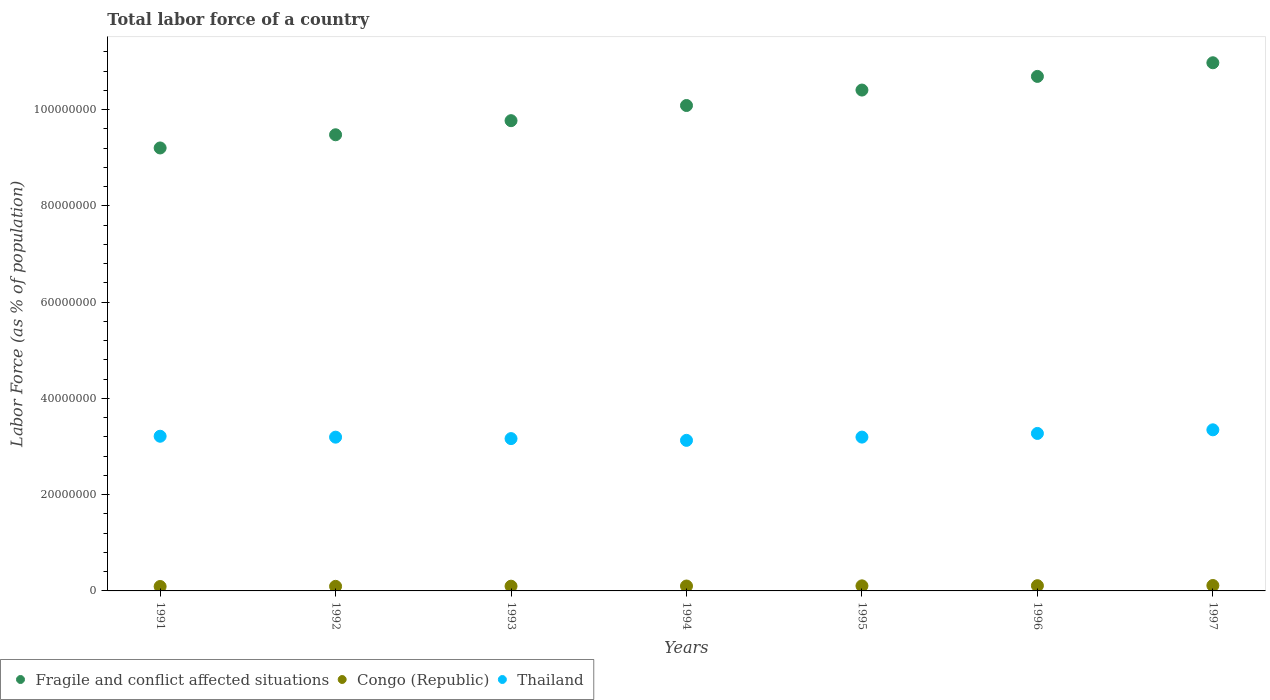How many different coloured dotlines are there?
Your answer should be very brief. 3. Is the number of dotlines equal to the number of legend labels?
Your answer should be compact. Yes. What is the percentage of labor force in Thailand in 1995?
Your answer should be compact. 3.20e+07. Across all years, what is the maximum percentage of labor force in Thailand?
Your answer should be very brief. 3.35e+07. Across all years, what is the minimum percentage of labor force in Thailand?
Your answer should be compact. 3.13e+07. In which year was the percentage of labor force in Thailand maximum?
Give a very brief answer. 1997. In which year was the percentage of labor force in Fragile and conflict affected situations minimum?
Ensure brevity in your answer.  1991. What is the total percentage of labor force in Congo (Republic) in the graph?
Provide a succinct answer. 7.14e+06. What is the difference between the percentage of labor force in Congo (Republic) in 1994 and that in 1997?
Your response must be concise. -1.05e+05. What is the difference between the percentage of labor force in Fragile and conflict affected situations in 1992 and the percentage of labor force in Thailand in 1996?
Provide a short and direct response. 6.20e+07. What is the average percentage of labor force in Thailand per year?
Your answer should be very brief. 3.22e+07. In the year 1993, what is the difference between the percentage of labor force in Fragile and conflict affected situations and percentage of labor force in Thailand?
Give a very brief answer. 6.60e+07. In how many years, is the percentage of labor force in Fragile and conflict affected situations greater than 92000000 %?
Your answer should be compact. 7. What is the ratio of the percentage of labor force in Thailand in 1995 to that in 1997?
Provide a succinct answer. 0.95. Is the percentage of labor force in Congo (Republic) in 1991 less than that in 1996?
Your response must be concise. Yes. What is the difference between the highest and the second highest percentage of labor force in Thailand?
Your response must be concise. 7.50e+05. What is the difference between the highest and the lowest percentage of labor force in Thailand?
Offer a very short reply. 2.19e+06. In how many years, is the percentage of labor force in Fragile and conflict affected situations greater than the average percentage of labor force in Fragile and conflict affected situations taken over all years?
Give a very brief answer. 3. Is the sum of the percentage of labor force in Thailand in 1996 and 1997 greater than the maximum percentage of labor force in Fragile and conflict affected situations across all years?
Offer a terse response. No. How many dotlines are there?
Your answer should be very brief. 3. What is the difference between two consecutive major ticks on the Y-axis?
Your answer should be very brief. 2.00e+07. Are the values on the major ticks of Y-axis written in scientific E-notation?
Keep it short and to the point. No. What is the title of the graph?
Ensure brevity in your answer.  Total labor force of a country. What is the label or title of the Y-axis?
Keep it short and to the point. Labor Force (as % of population). What is the Labor Force (as % of population) in Fragile and conflict affected situations in 1991?
Ensure brevity in your answer.  9.20e+07. What is the Labor Force (as % of population) in Congo (Republic) in 1991?
Your answer should be compact. 9.21e+05. What is the Labor Force (as % of population) of Thailand in 1991?
Give a very brief answer. 3.21e+07. What is the Labor Force (as % of population) of Fragile and conflict affected situations in 1992?
Make the answer very short. 9.48e+07. What is the Labor Force (as % of population) of Congo (Republic) in 1992?
Make the answer very short. 9.51e+05. What is the Labor Force (as % of population) in Thailand in 1992?
Give a very brief answer. 3.19e+07. What is the Labor Force (as % of population) in Fragile and conflict affected situations in 1993?
Offer a very short reply. 9.77e+07. What is the Labor Force (as % of population) in Congo (Republic) in 1993?
Provide a short and direct response. 9.84e+05. What is the Labor Force (as % of population) of Thailand in 1993?
Give a very brief answer. 3.16e+07. What is the Labor Force (as % of population) in Fragile and conflict affected situations in 1994?
Your response must be concise. 1.01e+08. What is the Labor Force (as % of population) of Congo (Republic) in 1994?
Give a very brief answer. 1.02e+06. What is the Labor Force (as % of population) of Thailand in 1994?
Your answer should be compact. 3.13e+07. What is the Labor Force (as % of population) of Fragile and conflict affected situations in 1995?
Your response must be concise. 1.04e+08. What is the Labor Force (as % of population) in Congo (Republic) in 1995?
Make the answer very short. 1.05e+06. What is the Labor Force (as % of population) in Thailand in 1995?
Offer a very short reply. 3.20e+07. What is the Labor Force (as % of population) in Fragile and conflict affected situations in 1996?
Keep it short and to the point. 1.07e+08. What is the Labor Force (as % of population) in Congo (Republic) in 1996?
Your response must be concise. 1.09e+06. What is the Labor Force (as % of population) of Thailand in 1996?
Provide a short and direct response. 3.27e+07. What is the Labor Force (as % of population) of Fragile and conflict affected situations in 1997?
Provide a short and direct response. 1.10e+08. What is the Labor Force (as % of population) of Congo (Republic) in 1997?
Give a very brief answer. 1.12e+06. What is the Labor Force (as % of population) in Thailand in 1997?
Your answer should be very brief. 3.35e+07. Across all years, what is the maximum Labor Force (as % of population) in Fragile and conflict affected situations?
Provide a short and direct response. 1.10e+08. Across all years, what is the maximum Labor Force (as % of population) of Congo (Republic)?
Make the answer very short. 1.12e+06. Across all years, what is the maximum Labor Force (as % of population) in Thailand?
Offer a terse response. 3.35e+07. Across all years, what is the minimum Labor Force (as % of population) in Fragile and conflict affected situations?
Your answer should be compact. 9.20e+07. Across all years, what is the minimum Labor Force (as % of population) of Congo (Republic)?
Ensure brevity in your answer.  9.21e+05. Across all years, what is the minimum Labor Force (as % of population) of Thailand?
Your response must be concise. 3.13e+07. What is the total Labor Force (as % of population) of Fragile and conflict affected situations in the graph?
Offer a terse response. 7.06e+08. What is the total Labor Force (as % of population) of Congo (Republic) in the graph?
Offer a very short reply. 7.14e+06. What is the total Labor Force (as % of population) in Thailand in the graph?
Make the answer very short. 2.25e+08. What is the difference between the Labor Force (as % of population) of Fragile and conflict affected situations in 1991 and that in 1992?
Make the answer very short. -2.74e+06. What is the difference between the Labor Force (as % of population) of Congo (Republic) in 1991 and that in 1992?
Your answer should be very brief. -3.00e+04. What is the difference between the Labor Force (as % of population) of Thailand in 1991 and that in 1992?
Ensure brevity in your answer.  1.91e+05. What is the difference between the Labor Force (as % of population) of Fragile and conflict affected situations in 1991 and that in 1993?
Your answer should be compact. -5.67e+06. What is the difference between the Labor Force (as % of population) in Congo (Republic) in 1991 and that in 1993?
Provide a short and direct response. -6.29e+04. What is the difference between the Labor Force (as % of population) in Thailand in 1991 and that in 1993?
Your answer should be compact. 4.90e+05. What is the difference between the Labor Force (as % of population) of Fragile and conflict affected situations in 1991 and that in 1994?
Offer a terse response. -8.82e+06. What is the difference between the Labor Force (as % of population) of Congo (Republic) in 1991 and that in 1994?
Make the answer very short. -9.71e+04. What is the difference between the Labor Force (as % of population) in Thailand in 1991 and that in 1994?
Your answer should be compact. 8.55e+05. What is the difference between the Labor Force (as % of population) of Fragile and conflict affected situations in 1991 and that in 1995?
Ensure brevity in your answer.  -1.20e+07. What is the difference between the Labor Force (as % of population) in Congo (Republic) in 1991 and that in 1995?
Provide a short and direct response. -1.31e+05. What is the difference between the Labor Force (as % of population) in Thailand in 1991 and that in 1995?
Ensure brevity in your answer.  1.80e+05. What is the difference between the Labor Force (as % of population) in Fragile and conflict affected situations in 1991 and that in 1996?
Give a very brief answer. -1.49e+07. What is the difference between the Labor Force (as % of population) in Congo (Republic) in 1991 and that in 1996?
Your answer should be compact. -1.66e+05. What is the difference between the Labor Force (as % of population) in Thailand in 1991 and that in 1996?
Keep it short and to the point. -5.83e+05. What is the difference between the Labor Force (as % of population) of Fragile and conflict affected situations in 1991 and that in 1997?
Ensure brevity in your answer.  -1.77e+07. What is the difference between the Labor Force (as % of population) in Congo (Republic) in 1991 and that in 1997?
Give a very brief answer. -2.03e+05. What is the difference between the Labor Force (as % of population) of Thailand in 1991 and that in 1997?
Your answer should be compact. -1.33e+06. What is the difference between the Labor Force (as % of population) in Fragile and conflict affected situations in 1992 and that in 1993?
Your response must be concise. -2.93e+06. What is the difference between the Labor Force (as % of population) in Congo (Republic) in 1992 and that in 1993?
Your answer should be very brief. -3.29e+04. What is the difference between the Labor Force (as % of population) of Thailand in 1992 and that in 1993?
Give a very brief answer. 2.99e+05. What is the difference between the Labor Force (as % of population) in Fragile and conflict affected situations in 1992 and that in 1994?
Give a very brief answer. -6.08e+06. What is the difference between the Labor Force (as % of population) of Congo (Republic) in 1992 and that in 1994?
Provide a succinct answer. -6.71e+04. What is the difference between the Labor Force (as % of population) in Thailand in 1992 and that in 1994?
Your answer should be compact. 6.64e+05. What is the difference between the Labor Force (as % of population) in Fragile and conflict affected situations in 1992 and that in 1995?
Your response must be concise. -9.29e+06. What is the difference between the Labor Force (as % of population) in Congo (Republic) in 1992 and that in 1995?
Your answer should be compact. -1.01e+05. What is the difference between the Labor Force (as % of population) in Thailand in 1992 and that in 1995?
Provide a succinct answer. -1.12e+04. What is the difference between the Labor Force (as % of population) in Fragile and conflict affected situations in 1992 and that in 1996?
Provide a succinct answer. -1.21e+07. What is the difference between the Labor Force (as % of population) of Congo (Republic) in 1992 and that in 1996?
Your response must be concise. -1.36e+05. What is the difference between the Labor Force (as % of population) in Thailand in 1992 and that in 1996?
Provide a succinct answer. -7.74e+05. What is the difference between the Labor Force (as % of population) in Fragile and conflict affected situations in 1992 and that in 1997?
Give a very brief answer. -1.50e+07. What is the difference between the Labor Force (as % of population) in Congo (Republic) in 1992 and that in 1997?
Make the answer very short. -1.73e+05. What is the difference between the Labor Force (as % of population) in Thailand in 1992 and that in 1997?
Ensure brevity in your answer.  -1.52e+06. What is the difference between the Labor Force (as % of population) of Fragile and conflict affected situations in 1993 and that in 1994?
Offer a very short reply. -3.15e+06. What is the difference between the Labor Force (as % of population) of Congo (Republic) in 1993 and that in 1994?
Make the answer very short. -3.42e+04. What is the difference between the Labor Force (as % of population) of Thailand in 1993 and that in 1994?
Your response must be concise. 3.65e+05. What is the difference between the Labor Force (as % of population) in Fragile and conflict affected situations in 1993 and that in 1995?
Your answer should be very brief. -6.36e+06. What is the difference between the Labor Force (as % of population) in Congo (Republic) in 1993 and that in 1995?
Your answer should be very brief. -6.79e+04. What is the difference between the Labor Force (as % of population) of Thailand in 1993 and that in 1995?
Offer a terse response. -3.10e+05. What is the difference between the Labor Force (as % of population) of Fragile and conflict affected situations in 1993 and that in 1996?
Provide a succinct answer. -9.20e+06. What is the difference between the Labor Force (as % of population) in Congo (Republic) in 1993 and that in 1996?
Provide a succinct answer. -1.03e+05. What is the difference between the Labor Force (as % of population) of Thailand in 1993 and that in 1996?
Provide a succinct answer. -1.07e+06. What is the difference between the Labor Force (as % of population) of Fragile and conflict affected situations in 1993 and that in 1997?
Offer a very short reply. -1.20e+07. What is the difference between the Labor Force (as % of population) in Congo (Republic) in 1993 and that in 1997?
Make the answer very short. -1.40e+05. What is the difference between the Labor Force (as % of population) in Thailand in 1993 and that in 1997?
Offer a terse response. -1.82e+06. What is the difference between the Labor Force (as % of population) in Fragile and conflict affected situations in 1994 and that in 1995?
Offer a terse response. -3.21e+06. What is the difference between the Labor Force (as % of population) in Congo (Republic) in 1994 and that in 1995?
Provide a succinct answer. -3.37e+04. What is the difference between the Labor Force (as % of population) in Thailand in 1994 and that in 1995?
Offer a terse response. -6.75e+05. What is the difference between the Labor Force (as % of population) of Fragile and conflict affected situations in 1994 and that in 1996?
Provide a short and direct response. -6.04e+06. What is the difference between the Labor Force (as % of population) in Congo (Republic) in 1994 and that in 1996?
Provide a short and direct response. -6.90e+04. What is the difference between the Labor Force (as % of population) in Thailand in 1994 and that in 1996?
Your response must be concise. -1.44e+06. What is the difference between the Labor Force (as % of population) of Fragile and conflict affected situations in 1994 and that in 1997?
Make the answer very short. -8.88e+06. What is the difference between the Labor Force (as % of population) in Congo (Republic) in 1994 and that in 1997?
Ensure brevity in your answer.  -1.05e+05. What is the difference between the Labor Force (as % of population) of Thailand in 1994 and that in 1997?
Keep it short and to the point. -2.19e+06. What is the difference between the Labor Force (as % of population) of Fragile and conflict affected situations in 1995 and that in 1996?
Ensure brevity in your answer.  -2.84e+06. What is the difference between the Labor Force (as % of population) in Congo (Republic) in 1995 and that in 1996?
Offer a very short reply. -3.52e+04. What is the difference between the Labor Force (as % of population) in Thailand in 1995 and that in 1996?
Keep it short and to the point. -7.63e+05. What is the difference between the Labor Force (as % of population) of Fragile and conflict affected situations in 1995 and that in 1997?
Keep it short and to the point. -5.67e+06. What is the difference between the Labor Force (as % of population) of Congo (Republic) in 1995 and that in 1997?
Provide a succinct answer. -7.17e+04. What is the difference between the Labor Force (as % of population) in Thailand in 1995 and that in 1997?
Offer a terse response. -1.51e+06. What is the difference between the Labor Force (as % of population) in Fragile and conflict affected situations in 1996 and that in 1997?
Give a very brief answer. -2.83e+06. What is the difference between the Labor Force (as % of population) of Congo (Republic) in 1996 and that in 1997?
Your answer should be compact. -3.65e+04. What is the difference between the Labor Force (as % of population) in Thailand in 1996 and that in 1997?
Keep it short and to the point. -7.50e+05. What is the difference between the Labor Force (as % of population) of Fragile and conflict affected situations in 1991 and the Labor Force (as % of population) of Congo (Republic) in 1992?
Your answer should be very brief. 9.11e+07. What is the difference between the Labor Force (as % of population) in Fragile and conflict affected situations in 1991 and the Labor Force (as % of population) in Thailand in 1992?
Your answer should be very brief. 6.01e+07. What is the difference between the Labor Force (as % of population) in Congo (Republic) in 1991 and the Labor Force (as % of population) in Thailand in 1992?
Your answer should be very brief. -3.10e+07. What is the difference between the Labor Force (as % of population) of Fragile and conflict affected situations in 1991 and the Labor Force (as % of population) of Congo (Republic) in 1993?
Your answer should be compact. 9.10e+07. What is the difference between the Labor Force (as % of population) in Fragile and conflict affected situations in 1991 and the Labor Force (as % of population) in Thailand in 1993?
Ensure brevity in your answer.  6.04e+07. What is the difference between the Labor Force (as % of population) of Congo (Republic) in 1991 and the Labor Force (as % of population) of Thailand in 1993?
Offer a very short reply. -3.07e+07. What is the difference between the Labor Force (as % of population) of Fragile and conflict affected situations in 1991 and the Labor Force (as % of population) of Congo (Republic) in 1994?
Your response must be concise. 9.10e+07. What is the difference between the Labor Force (as % of population) of Fragile and conflict affected situations in 1991 and the Labor Force (as % of population) of Thailand in 1994?
Your answer should be very brief. 6.07e+07. What is the difference between the Labor Force (as % of population) in Congo (Republic) in 1991 and the Labor Force (as % of population) in Thailand in 1994?
Ensure brevity in your answer.  -3.04e+07. What is the difference between the Labor Force (as % of population) of Fragile and conflict affected situations in 1991 and the Labor Force (as % of population) of Congo (Republic) in 1995?
Give a very brief answer. 9.10e+07. What is the difference between the Labor Force (as % of population) in Fragile and conflict affected situations in 1991 and the Labor Force (as % of population) in Thailand in 1995?
Give a very brief answer. 6.01e+07. What is the difference between the Labor Force (as % of population) of Congo (Republic) in 1991 and the Labor Force (as % of population) of Thailand in 1995?
Your answer should be compact. -3.10e+07. What is the difference between the Labor Force (as % of population) in Fragile and conflict affected situations in 1991 and the Labor Force (as % of population) in Congo (Republic) in 1996?
Give a very brief answer. 9.09e+07. What is the difference between the Labor Force (as % of population) in Fragile and conflict affected situations in 1991 and the Labor Force (as % of population) in Thailand in 1996?
Your answer should be very brief. 5.93e+07. What is the difference between the Labor Force (as % of population) of Congo (Republic) in 1991 and the Labor Force (as % of population) of Thailand in 1996?
Your answer should be compact. -3.18e+07. What is the difference between the Labor Force (as % of population) of Fragile and conflict affected situations in 1991 and the Labor Force (as % of population) of Congo (Republic) in 1997?
Your answer should be very brief. 9.09e+07. What is the difference between the Labor Force (as % of population) of Fragile and conflict affected situations in 1991 and the Labor Force (as % of population) of Thailand in 1997?
Give a very brief answer. 5.86e+07. What is the difference between the Labor Force (as % of population) of Congo (Republic) in 1991 and the Labor Force (as % of population) of Thailand in 1997?
Offer a very short reply. -3.25e+07. What is the difference between the Labor Force (as % of population) in Fragile and conflict affected situations in 1992 and the Labor Force (as % of population) in Congo (Republic) in 1993?
Your answer should be compact. 9.38e+07. What is the difference between the Labor Force (as % of population) in Fragile and conflict affected situations in 1992 and the Labor Force (as % of population) in Thailand in 1993?
Give a very brief answer. 6.31e+07. What is the difference between the Labor Force (as % of population) in Congo (Republic) in 1992 and the Labor Force (as % of population) in Thailand in 1993?
Your answer should be compact. -3.07e+07. What is the difference between the Labor Force (as % of population) in Fragile and conflict affected situations in 1992 and the Labor Force (as % of population) in Congo (Republic) in 1994?
Your answer should be very brief. 9.37e+07. What is the difference between the Labor Force (as % of population) in Fragile and conflict affected situations in 1992 and the Labor Force (as % of population) in Thailand in 1994?
Ensure brevity in your answer.  6.35e+07. What is the difference between the Labor Force (as % of population) of Congo (Republic) in 1992 and the Labor Force (as % of population) of Thailand in 1994?
Make the answer very short. -3.03e+07. What is the difference between the Labor Force (as % of population) in Fragile and conflict affected situations in 1992 and the Labor Force (as % of population) in Congo (Republic) in 1995?
Provide a succinct answer. 9.37e+07. What is the difference between the Labor Force (as % of population) in Fragile and conflict affected situations in 1992 and the Labor Force (as % of population) in Thailand in 1995?
Offer a terse response. 6.28e+07. What is the difference between the Labor Force (as % of population) in Congo (Republic) in 1992 and the Labor Force (as % of population) in Thailand in 1995?
Keep it short and to the point. -3.10e+07. What is the difference between the Labor Force (as % of population) of Fragile and conflict affected situations in 1992 and the Labor Force (as % of population) of Congo (Republic) in 1996?
Ensure brevity in your answer.  9.37e+07. What is the difference between the Labor Force (as % of population) in Fragile and conflict affected situations in 1992 and the Labor Force (as % of population) in Thailand in 1996?
Keep it short and to the point. 6.20e+07. What is the difference between the Labor Force (as % of population) of Congo (Republic) in 1992 and the Labor Force (as % of population) of Thailand in 1996?
Make the answer very short. -3.18e+07. What is the difference between the Labor Force (as % of population) in Fragile and conflict affected situations in 1992 and the Labor Force (as % of population) in Congo (Republic) in 1997?
Offer a very short reply. 9.36e+07. What is the difference between the Labor Force (as % of population) of Fragile and conflict affected situations in 1992 and the Labor Force (as % of population) of Thailand in 1997?
Ensure brevity in your answer.  6.13e+07. What is the difference between the Labor Force (as % of population) of Congo (Republic) in 1992 and the Labor Force (as % of population) of Thailand in 1997?
Your answer should be very brief. -3.25e+07. What is the difference between the Labor Force (as % of population) of Fragile and conflict affected situations in 1993 and the Labor Force (as % of population) of Congo (Republic) in 1994?
Offer a very short reply. 9.67e+07. What is the difference between the Labor Force (as % of population) in Fragile and conflict affected situations in 1993 and the Labor Force (as % of population) in Thailand in 1994?
Offer a terse response. 6.64e+07. What is the difference between the Labor Force (as % of population) of Congo (Republic) in 1993 and the Labor Force (as % of population) of Thailand in 1994?
Give a very brief answer. -3.03e+07. What is the difference between the Labor Force (as % of population) of Fragile and conflict affected situations in 1993 and the Labor Force (as % of population) of Congo (Republic) in 1995?
Keep it short and to the point. 9.66e+07. What is the difference between the Labor Force (as % of population) in Fragile and conflict affected situations in 1993 and the Labor Force (as % of population) in Thailand in 1995?
Your response must be concise. 6.57e+07. What is the difference between the Labor Force (as % of population) in Congo (Republic) in 1993 and the Labor Force (as % of population) in Thailand in 1995?
Your answer should be compact. -3.10e+07. What is the difference between the Labor Force (as % of population) in Fragile and conflict affected situations in 1993 and the Labor Force (as % of population) in Congo (Republic) in 1996?
Your answer should be very brief. 9.66e+07. What is the difference between the Labor Force (as % of population) in Fragile and conflict affected situations in 1993 and the Labor Force (as % of population) in Thailand in 1996?
Make the answer very short. 6.50e+07. What is the difference between the Labor Force (as % of population) in Congo (Republic) in 1993 and the Labor Force (as % of population) in Thailand in 1996?
Make the answer very short. -3.17e+07. What is the difference between the Labor Force (as % of population) in Fragile and conflict affected situations in 1993 and the Labor Force (as % of population) in Congo (Republic) in 1997?
Your response must be concise. 9.66e+07. What is the difference between the Labor Force (as % of population) of Fragile and conflict affected situations in 1993 and the Labor Force (as % of population) of Thailand in 1997?
Your answer should be compact. 6.42e+07. What is the difference between the Labor Force (as % of population) in Congo (Republic) in 1993 and the Labor Force (as % of population) in Thailand in 1997?
Make the answer very short. -3.25e+07. What is the difference between the Labor Force (as % of population) of Fragile and conflict affected situations in 1994 and the Labor Force (as % of population) of Congo (Republic) in 1995?
Your answer should be compact. 9.98e+07. What is the difference between the Labor Force (as % of population) in Fragile and conflict affected situations in 1994 and the Labor Force (as % of population) in Thailand in 1995?
Make the answer very short. 6.89e+07. What is the difference between the Labor Force (as % of population) in Congo (Republic) in 1994 and the Labor Force (as % of population) in Thailand in 1995?
Ensure brevity in your answer.  -3.09e+07. What is the difference between the Labor Force (as % of population) in Fragile and conflict affected situations in 1994 and the Labor Force (as % of population) in Congo (Republic) in 1996?
Your answer should be compact. 9.98e+07. What is the difference between the Labor Force (as % of population) in Fragile and conflict affected situations in 1994 and the Labor Force (as % of population) in Thailand in 1996?
Your response must be concise. 6.81e+07. What is the difference between the Labor Force (as % of population) of Congo (Republic) in 1994 and the Labor Force (as % of population) of Thailand in 1996?
Offer a very short reply. -3.17e+07. What is the difference between the Labor Force (as % of population) in Fragile and conflict affected situations in 1994 and the Labor Force (as % of population) in Congo (Republic) in 1997?
Keep it short and to the point. 9.97e+07. What is the difference between the Labor Force (as % of population) in Fragile and conflict affected situations in 1994 and the Labor Force (as % of population) in Thailand in 1997?
Your answer should be very brief. 6.74e+07. What is the difference between the Labor Force (as % of population) of Congo (Republic) in 1994 and the Labor Force (as % of population) of Thailand in 1997?
Offer a terse response. -3.24e+07. What is the difference between the Labor Force (as % of population) of Fragile and conflict affected situations in 1995 and the Labor Force (as % of population) of Congo (Republic) in 1996?
Provide a succinct answer. 1.03e+08. What is the difference between the Labor Force (as % of population) of Fragile and conflict affected situations in 1995 and the Labor Force (as % of population) of Thailand in 1996?
Ensure brevity in your answer.  7.13e+07. What is the difference between the Labor Force (as % of population) in Congo (Republic) in 1995 and the Labor Force (as % of population) in Thailand in 1996?
Ensure brevity in your answer.  -3.17e+07. What is the difference between the Labor Force (as % of population) of Fragile and conflict affected situations in 1995 and the Labor Force (as % of population) of Congo (Republic) in 1997?
Offer a very short reply. 1.03e+08. What is the difference between the Labor Force (as % of population) in Fragile and conflict affected situations in 1995 and the Labor Force (as % of population) in Thailand in 1997?
Make the answer very short. 7.06e+07. What is the difference between the Labor Force (as % of population) of Congo (Republic) in 1995 and the Labor Force (as % of population) of Thailand in 1997?
Give a very brief answer. -3.24e+07. What is the difference between the Labor Force (as % of population) in Fragile and conflict affected situations in 1996 and the Labor Force (as % of population) in Congo (Republic) in 1997?
Your response must be concise. 1.06e+08. What is the difference between the Labor Force (as % of population) of Fragile and conflict affected situations in 1996 and the Labor Force (as % of population) of Thailand in 1997?
Provide a succinct answer. 7.34e+07. What is the difference between the Labor Force (as % of population) in Congo (Republic) in 1996 and the Labor Force (as % of population) in Thailand in 1997?
Provide a short and direct response. -3.24e+07. What is the average Labor Force (as % of population) in Fragile and conflict affected situations per year?
Make the answer very short. 1.01e+08. What is the average Labor Force (as % of population) of Congo (Republic) per year?
Keep it short and to the point. 1.02e+06. What is the average Labor Force (as % of population) of Thailand per year?
Provide a short and direct response. 3.22e+07. In the year 1991, what is the difference between the Labor Force (as % of population) of Fragile and conflict affected situations and Labor Force (as % of population) of Congo (Republic)?
Offer a terse response. 9.11e+07. In the year 1991, what is the difference between the Labor Force (as % of population) of Fragile and conflict affected situations and Labor Force (as % of population) of Thailand?
Keep it short and to the point. 5.99e+07. In the year 1991, what is the difference between the Labor Force (as % of population) of Congo (Republic) and Labor Force (as % of population) of Thailand?
Provide a succinct answer. -3.12e+07. In the year 1992, what is the difference between the Labor Force (as % of population) of Fragile and conflict affected situations and Labor Force (as % of population) of Congo (Republic)?
Offer a very short reply. 9.38e+07. In the year 1992, what is the difference between the Labor Force (as % of population) of Fragile and conflict affected situations and Labor Force (as % of population) of Thailand?
Give a very brief answer. 6.28e+07. In the year 1992, what is the difference between the Labor Force (as % of population) of Congo (Republic) and Labor Force (as % of population) of Thailand?
Make the answer very short. -3.10e+07. In the year 1993, what is the difference between the Labor Force (as % of population) of Fragile and conflict affected situations and Labor Force (as % of population) of Congo (Republic)?
Offer a very short reply. 9.67e+07. In the year 1993, what is the difference between the Labor Force (as % of population) of Fragile and conflict affected situations and Labor Force (as % of population) of Thailand?
Offer a terse response. 6.60e+07. In the year 1993, what is the difference between the Labor Force (as % of population) of Congo (Republic) and Labor Force (as % of population) of Thailand?
Give a very brief answer. -3.07e+07. In the year 1994, what is the difference between the Labor Force (as % of population) in Fragile and conflict affected situations and Labor Force (as % of population) in Congo (Republic)?
Provide a succinct answer. 9.98e+07. In the year 1994, what is the difference between the Labor Force (as % of population) in Fragile and conflict affected situations and Labor Force (as % of population) in Thailand?
Provide a succinct answer. 6.96e+07. In the year 1994, what is the difference between the Labor Force (as % of population) of Congo (Republic) and Labor Force (as % of population) of Thailand?
Give a very brief answer. -3.03e+07. In the year 1995, what is the difference between the Labor Force (as % of population) in Fragile and conflict affected situations and Labor Force (as % of population) in Congo (Republic)?
Provide a short and direct response. 1.03e+08. In the year 1995, what is the difference between the Labor Force (as % of population) in Fragile and conflict affected situations and Labor Force (as % of population) in Thailand?
Give a very brief answer. 7.21e+07. In the year 1995, what is the difference between the Labor Force (as % of population) in Congo (Republic) and Labor Force (as % of population) in Thailand?
Your response must be concise. -3.09e+07. In the year 1996, what is the difference between the Labor Force (as % of population) in Fragile and conflict affected situations and Labor Force (as % of population) in Congo (Republic)?
Your response must be concise. 1.06e+08. In the year 1996, what is the difference between the Labor Force (as % of population) in Fragile and conflict affected situations and Labor Force (as % of population) in Thailand?
Your answer should be compact. 7.42e+07. In the year 1996, what is the difference between the Labor Force (as % of population) of Congo (Republic) and Labor Force (as % of population) of Thailand?
Make the answer very short. -3.16e+07. In the year 1997, what is the difference between the Labor Force (as % of population) in Fragile and conflict affected situations and Labor Force (as % of population) in Congo (Republic)?
Offer a very short reply. 1.09e+08. In the year 1997, what is the difference between the Labor Force (as % of population) of Fragile and conflict affected situations and Labor Force (as % of population) of Thailand?
Give a very brief answer. 7.63e+07. In the year 1997, what is the difference between the Labor Force (as % of population) of Congo (Republic) and Labor Force (as % of population) of Thailand?
Give a very brief answer. -3.23e+07. What is the ratio of the Labor Force (as % of population) of Fragile and conflict affected situations in 1991 to that in 1992?
Offer a very short reply. 0.97. What is the ratio of the Labor Force (as % of population) of Congo (Republic) in 1991 to that in 1992?
Keep it short and to the point. 0.97. What is the ratio of the Labor Force (as % of population) in Fragile and conflict affected situations in 1991 to that in 1993?
Offer a terse response. 0.94. What is the ratio of the Labor Force (as % of population) in Congo (Republic) in 1991 to that in 1993?
Give a very brief answer. 0.94. What is the ratio of the Labor Force (as % of population) in Thailand in 1991 to that in 1993?
Ensure brevity in your answer.  1.02. What is the ratio of the Labor Force (as % of population) of Fragile and conflict affected situations in 1991 to that in 1994?
Your answer should be very brief. 0.91. What is the ratio of the Labor Force (as % of population) in Congo (Republic) in 1991 to that in 1994?
Your response must be concise. 0.9. What is the ratio of the Labor Force (as % of population) of Thailand in 1991 to that in 1994?
Make the answer very short. 1.03. What is the ratio of the Labor Force (as % of population) in Fragile and conflict affected situations in 1991 to that in 1995?
Keep it short and to the point. 0.88. What is the ratio of the Labor Force (as % of population) of Congo (Republic) in 1991 to that in 1995?
Offer a terse response. 0.88. What is the ratio of the Labor Force (as % of population) in Thailand in 1991 to that in 1995?
Keep it short and to the point. 1.01. What is the ratio of the Labor Force (as % of population) in Fragile and conflict affected situations in 1991 to that in 1996?
Ensure brevity in your answer.  0.86. What is the ratio of the Labor Force (as % of population) in Congo (Republic) in 1991 to that in 1996?
Your response must be concise. 0.85. What is the ratio of the Labor Force (as % of population) in Thailand in 1991 to that in 1996?
Your answer should be compact. 0.98. What is the ratio of the Labor Force (as % of population) of Fragile and conflict affected situations in 1991 to that in 1997?
Your answer should be compact. 0.84. What is the ratio of the Labor Force (as % of population) of Congo (Republic) in 1991 to that in 1997?
Provide a succinct answer. 0.82. What is the ratio of the Labor Force (as % of population) in Thailand in 1991 to that in 1997?
Keep it short and to the point. 0.96. What is the ratio of the Labor Force (as % of population) of Congo (Republic) in 1992 to that in 1993?
Offer a terse response. 0.97. What is the ratio of the Labor Force (as % of population) of Thailand in 1992 to that in 1993?
Provide a short and direct response. 1.01. What is the ratio of the Labor Force (as % of population) in Fragile and conflict affected situations in 1992 to that in 1994?
Provide a succinct answer. 0.94. What is the ratio of the Labor Force (as % of population) in Congo (Republic) in 1992 to that in 1994?
Give a very brief answer. 0.93. What is the ratio of the Labor Force (as % of population) in Thailand in 1992 to that in 1994?
Provide a succinct answer. 1.02. What is the ratio of the Labor Force (as % of population) in Fragile and conflict affected situations in 1992 to that in 1995?
Provide a succinct answer. 0.91. What is the ratio of the Labor Force (as % of population) in Congo (Republic) in 1992 to that in 1995?
Make the answer very short. 0.9. What is the ratio of the Labor Force (as % of population) in Thailand in 1992 to that in 1995?
Keep it short and to the point. 1. What is the ratio of the Labor Force (as % of population) in Fragile and conflict affected situations in 1992 to that in 1996?
Keep it short and to the point. 0.89. What is the ratio of the Labor Force (as % of population) in Congo (Republic) in 1992 to that in 1996?
Make the answer very short. 0.87. What is the ratio of the Labor Force (as % of population) of Thailand in 1992 to that in 1996?
Offer a very short reply. 0.98. What is the ratio of the Labor Force (as % of population) of Fragile and conflict affected situations in 1992 to that in 1997?
Provide a short and direct response. 0.86. What is the ratio of the Labor Force (as % of population) of Congo (Republic) in 1992 to that in 1997?
Give a very brief answer. 0.85. What is the ratio of the Labor Force (as % of population) in Thailand in 1992 to that in 1997?
Give a very brief answer. 0.95. What is the ratio of the Labor Force (as % of population) of Fragile and conflict affected situations in 1993 to that in 1994?
Your answer should be compact. 0.97. What is the ratio of the Labor Force (as % of population) in Congo (Republic) in 1993 to that in 1994?
Provide a short and direct response. 0.97. What is the ratio of the Labor Force (as % of population) in Thailand in 1993 to that in 1994?
Provide a short and direct response. 1.01. What is the ratio of the Labor Force (as % of population) in Fragile and conflict affected situations in 1993 to that in 1995?
Keep it short and to the point. 0.94. What is the ratio of the Labor Force (as % of population) of Congo (Republic) in 1993 to that in 1995?
Your answer should be compact. 0.94. What is the ratio of the Labor Force (as % of population) in Thailand in 1993 to that in 1995?
Your response must be concise. 0.99. What is the ratio of the Labor Force (as % of population) of Fragile and conflict affected situations in 1993 to that in 1996?
Ensure brevity in your answer.  0.91. What is the ratio of the Labor Force (as % of population) in Congo (Republic) in 1993 to that in 1996?
Offer a very short reply. 0.91. What is the ratio of the Labor Force (as % of population) of Thailand in 1993 to that in 1996?
Offer a terse response. 0.97. What is the ratio of the Labor Force (as % of population) in Fragile and conflict affected situations in 1993 to that in 1997?
Offer a terse response. 0.89. What is the ratio of the Labor Force (as % of population) of Congo (Republic) in 1993 to that in 1997?
Ensure brevity in your answer.  0.88. What is the ratio of the Labor Force (as % of population) of Thailand in 1993 to that in 1997?
Offer a terse response. 0.95. What is the ratio of the Labor Force (as % of population) in Fragile and conflict affected situations in 1994 to that in 1995?
Your answer should be compact. 0.97. What is the ratio of the Labor Force (as % of population) in Congo (Republic) in 1994 to that in 1995?
Keep it short and to the point. 0.97. What is the ratio of the Labor Force (as % of population) in Thailand in 1994 to that in 1995?
Provide a succinct answer. 0.98. What is the ratio of the Labor Force (as % of population) of Fragile and conflict affected situations in 1994 to that in 1996?
Provide a short and direct response. 0.94. What is the ratio of the Labor Force (as % of population) of Congo (Republic) in 1994 to that in 1996?
Give a very brief answer. 0.94. What is the ratio of the Labor Force (as % of population) of Thailand in 1994 to that in 1996?
Offer a very short reply. 0.96. What is the ratio of the Labor Force (as % of population) of Fragile and conflict affected situations in 1994 to that in 1997?
Your answer should be compact. 0.92. What is the ratio of the Labor Force (as % of population) in Congo (Republic) in 1994 to that in 1997?
Offer a very short reply. 0.91. What is the ratio of the Labor Force (as % of population) of Thailand in 1994 to that in 1997?
Your response must be concise. 0.93. What is the ratio of the Labor Force (as % of population) of Fragile and conflict affected situations in 1995 to that in 1996?
Keep it short and to the point. 0.97. What is the ratio of the Labor Force (as % of population) of Congo (Republic) in 1995 to that in 1996?
Your answer should be very brief. 0.97. What is the ratio of the Labor Force (as % of population) in Thailand in 1995 to that in 1996?
Give a very brief answer. 0.98. What is the ratio of the Labor Force (as % of population) of Fragile and conflict affected situations in 1995 to that in 1997?
Offer a terse response. 0.95. What is the ratio of the Labor Force (as % of population) in Congo (Republic) in 1995 to that in 1997?
Your response must be concise. 0.94. What is the ratio of the Labor Force (as % of population) of Thailand in 1995 to that in 1997?
Ensure brevity in your answer.  0.95. What is the ratio of the Labor Force (as % of population) in Fragile and conflict affected situations in 1996 to that in 1997?
Keep it short and to the point. 0.97. What is the ratio of the Labor Force (as % of population) in Congo (Republic) in 1996 to that in 1997?
Offer a very short reply. 0.97. What is the ratio of the Labor Force (as % of population) in Thailand in 1996 to that in 1997?
Offer a very short reply. 0.98. What is the difference between the highest and the second highest Labor Force (as % of population) in Fragile and conflict affected situations?
Make the answer very short. 2.83e+06. What is the difference between the highest and the second highest Labor Force (as % of population) of Congo (Republic)?
Provide a succinct answer. 3.65e+04. What is the difference between the highest and the second highest Labor Force (as % of population) of Thailand?
Give a very brief answer. 7.50e+05. What is the difference between the highest and the lowest Labor Force (as % of population) in Fragile and conflict affected situations?
Keep it short and to the point. 1.77e+07. What is the difference between the highest and the lowest Labor Force (as % of population) in Congo (Republic)?
Ensure brevity in your answer.  2.03e+05. What is the difference between the highest and the lowest Labor Force (as % of population) in Thailand?
Make the answer very short. 2.19e+06. 